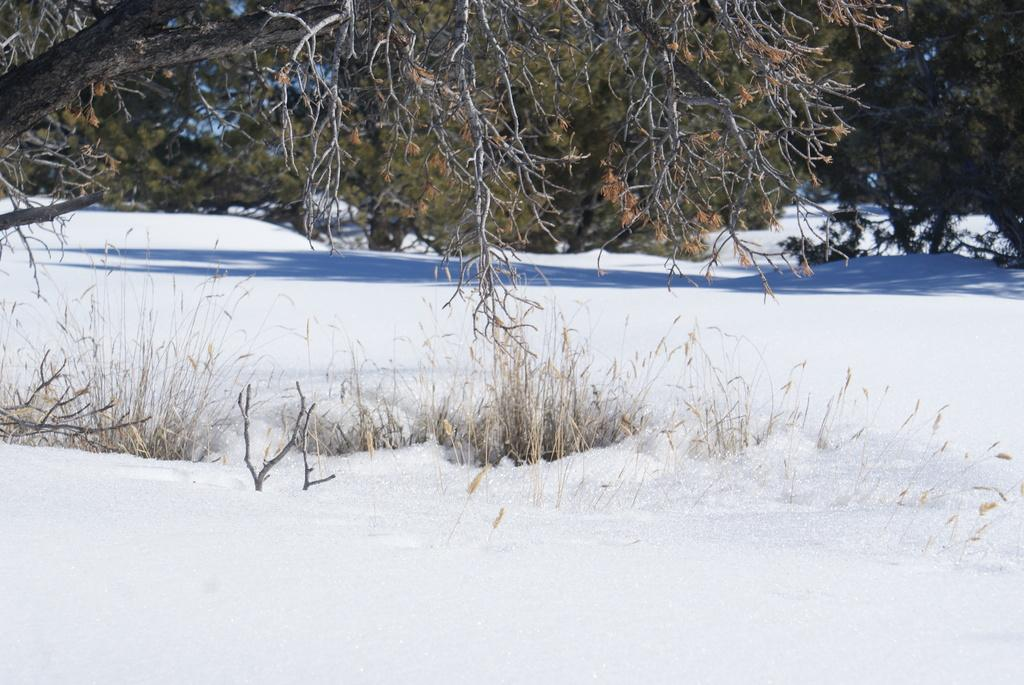What type of vegetation can be seen in the image? There are trees in the image. What is the ground covered with in the image? There is grass visible in the image. What weather condition is depicted in the image? There is snow in the image. What type of pencil can be seen in the image? There is no pencil present in the image. Is there a birthday celebration happening in the image? There is no indication of a birthday celebration in the image. 